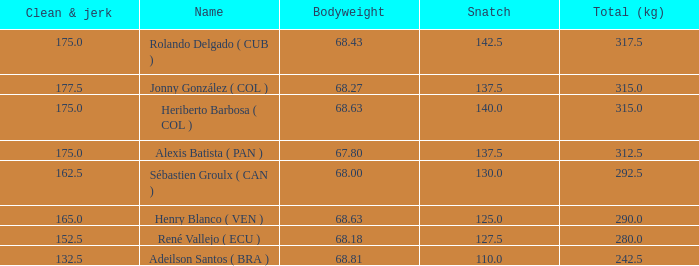Tell me the total number of snatches for clean and jerk more than 132.5 when the total kg was 315 and bodyweight was 68.63 1.0. 